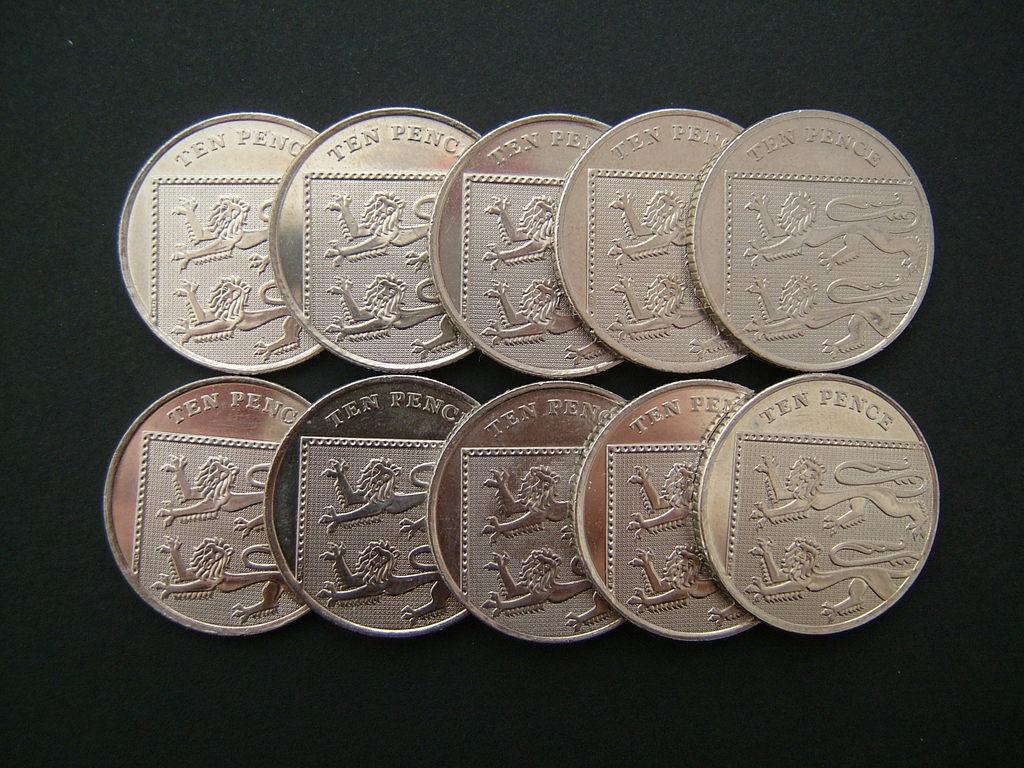Provide a one-sentence caption for the provided image. Ten golden colored coins that say Ten Pence. 